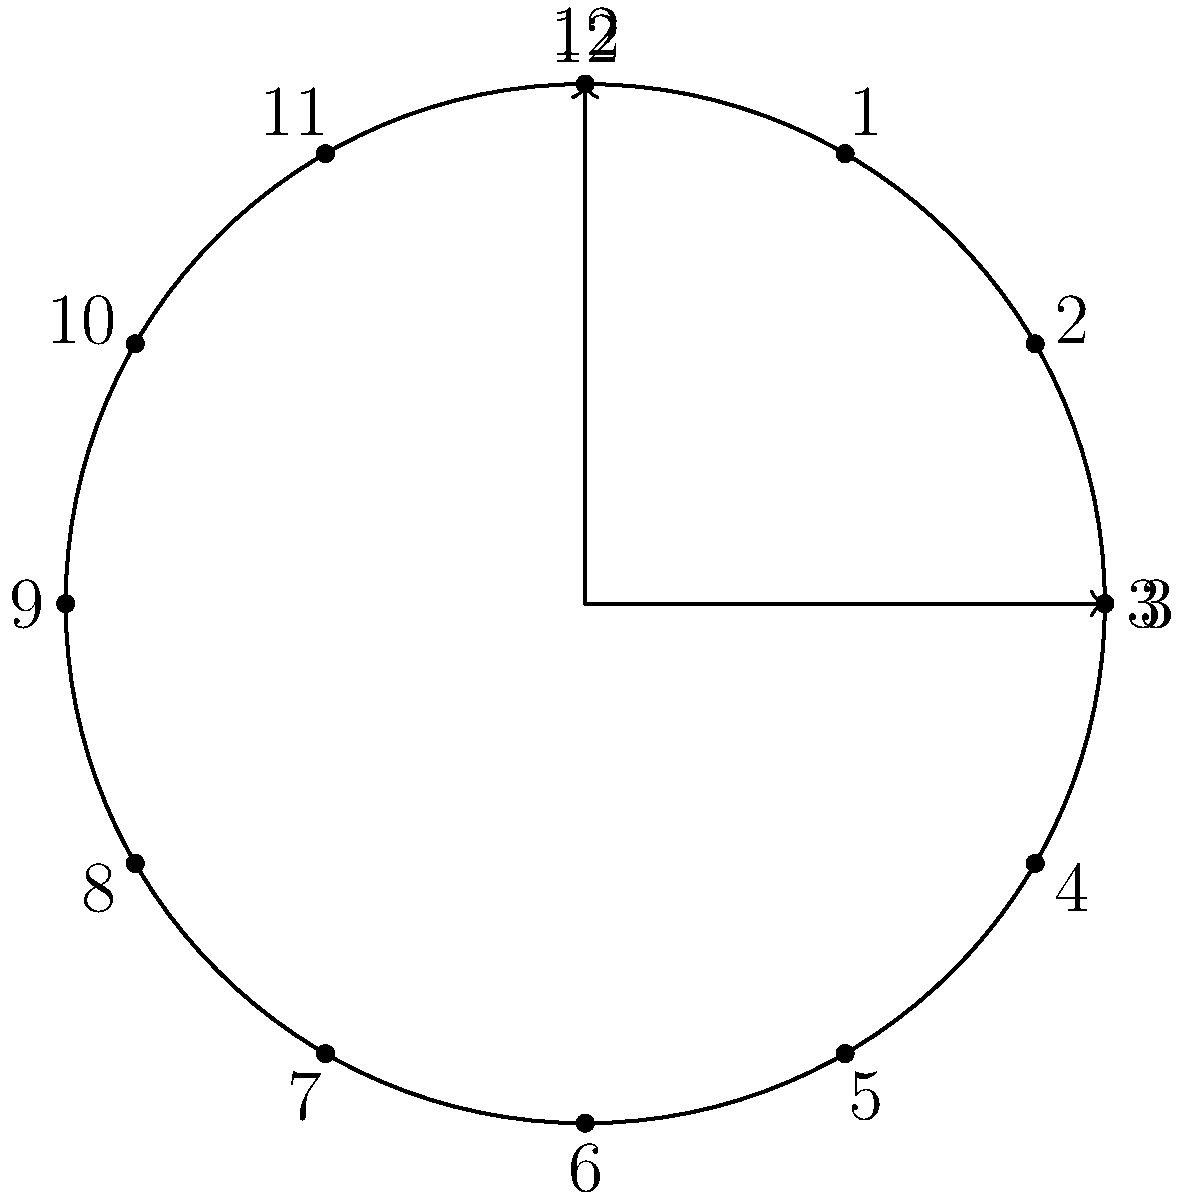Look at this clock face. When the hour hand moves from 12 to 3, how many degrees does it turn? Let's break this down step-by-step:

1. A clock face is divided into 12 equal parts, one for each hour.

2. A full rotation around the clock (from 12 back to 12) is 360 degrees.

3. To find how many degrees are between each hour, we divide 360 by 12:
   $$ \frac{360^\circ}{12} = 30^\circ $$

4. From 12 to 3, the hour hand moves through 3 of these 30-degree segments:
   $$ 3 \times 30^\circ = 90^\circ $$

5. Therefore, when the hour hand moves from 12 to 3, it turns 90 degrees.

This knowledge can help you visualize time intervals, which may be useful for timing activities or medication schedules.
Answer: 90 degrees 